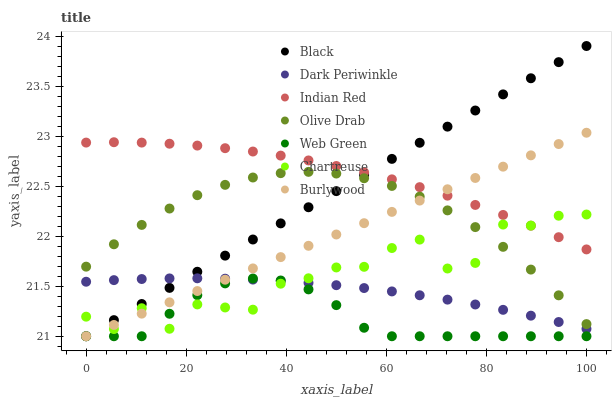Does Web Green have the minimum area under the curve?
Answer yes or no. Yes. Does Indian Red have the maximum area under the curve?
Answer yes or no. Yes. Does Chartreuse have the minimum area under the curve?
Answer yes or no. No. Does Chartreuse have the maximum area under the curve?
Answer yes or no. No. Is Black the smoothest?
Answer yes or no. Yes. Is Chartreuse the roughest?
Answer yes or no. Yes. Is Web Green the smoothest?
Answer yes or no. No. Is Web Green the roughest?
Answer yes or no. No. Does Burlywood have the lowest value?
Answer yes or no. Yes. Does Chartreuse have the lowest value?
Answer yes or no. No. Does Black have the highest value?
Answer yes or no. Yes. Does Chartreuse have the highest value?
Answer yes or no. No. Is Dark Periwinkle less than Indian Red?
Answer yes or no. Yes. Is Olive Drab greater than Web Green?
Answer yes or no. Yes. Does Black intersect Indian Red?
Answer yes or no. Yes. Is Black less than Indian Red?
Answer yes or no. No. Is Black greater than Indian Red?
Answer yes or no. No. Does Dark Periwinkle intersect Indian Red?
Answer yes or no. No. 